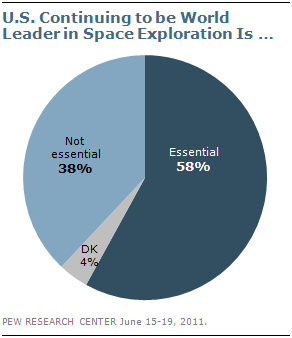Mention a couple of crucial points in this snapshot. Essential and non-essential differences in a pie graph refer to the relative importance of each component or category, with essential differences representing a larger portion of the total and having a greater impact on the overall outcome. The segment is divided into three parts. 